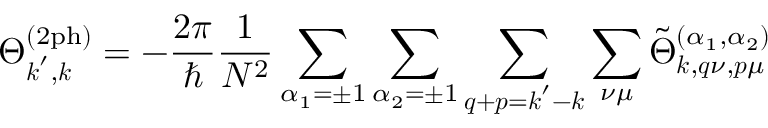<formula> <loc_0><loc_0><loc_500><loc_500>\Theta _ { k ^ { \prime } , k } ^ { ( 2 p h ) } = - \frac { 2 \pi } { } \frac { 1 } { N ^ { 2 } } \sum _ { \alpha _ { 1 } = \pm 1 } \sum _ { \alpha _ { 2 } = \pm 1 } \sum _ { q + p = k ^ { \prime } - k } \sum _ { \nu \mu } \tilde { \Theta } _ { k , q \nu , p \mu } ^ { ( \alpha _ { 1 } , \alpha _ { 2 } ) }</formula> 